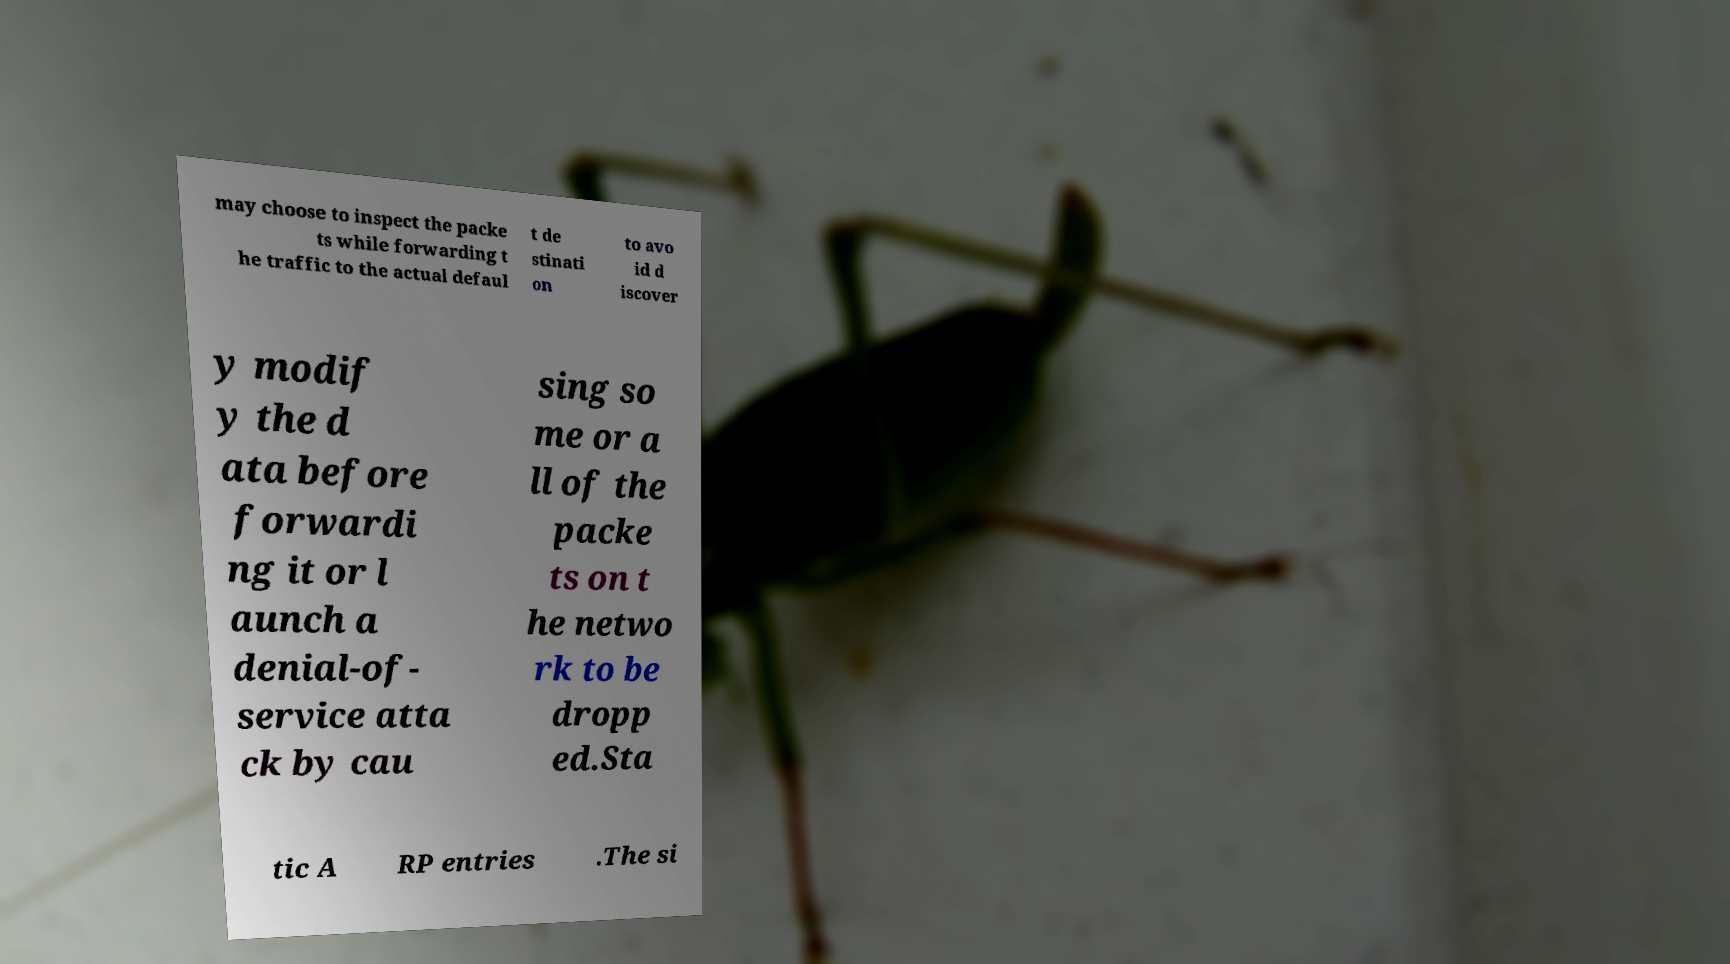There's text embedded in this image that I need extracted. Can you transcribe it verbatim? may choose to inspect the packe ts while forwarding t he traffic to the actual defaul t de stinati on to avo id d iscover y modif y the d ata before forwardi ng it or l aunch a denial-of- service atta ck by cau sing so me or a ll of the packe ts on t he netwo rk to be dropp ed.Sta tic A RP entries .The si 